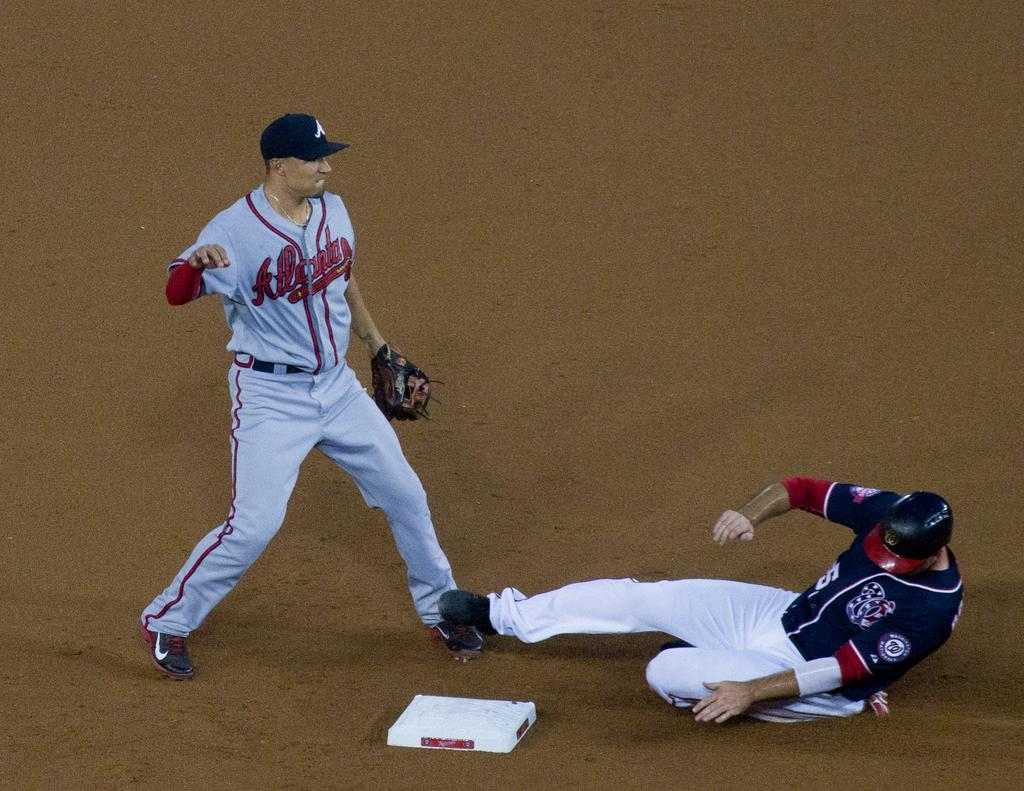<image>
Describe the image concisely. A player for the Atlanta Braves stands guard at base as a member of the Nationals slides in. 